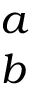<formula> <loc_0><loc_0><loc_500><loc_500>\begin{array} { l } { a } \\ { b } \end{array}</formula> 